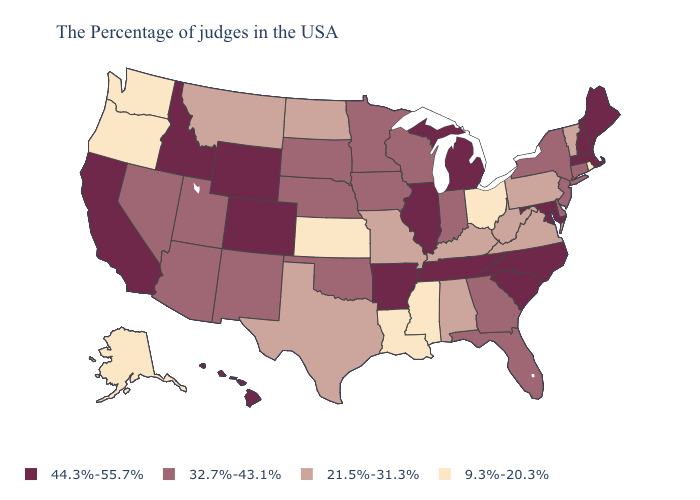Which states have the highest value in the USA?
Write a very short answer. Maine, Massachusetts, New Hampshire, Maryland, North Carolina, South Carolina, Michigan, Tennessee, Illinois, Arkansas, Wyoming, Colorado, Idaho, California, Hawaii. Name the states that have a value in the range 9.3%-20.3%?
Answer briefly. Rhode Island, Ohio, Mississippi, Louisiana, Kansas, Washington, Oregon, Alaska. Name the states that have a value in the range 21.5%-31.3%?
Concise answer only. Vermont, Pennsylvania, Virginia, West Virginia, Kentucky, Alabama, Missouri, Texas, North Dakota, Montana. What is the value of Tennessee?
Write a very short answer. 44.3%-55.7%. Name the states that have a value in the range 44.3%-55.7%?
Answer briefly. Maine, Massachusetts, New Hampshire, Maryland, North Carolina, South Carolina, Michigan, Tennessee, Illinois, Arkansas, Wyoming, Colorado, Idaho, California, Hawaii. How many symbols are there in the legend?
Keep it brief. 4. Which states have the lowest value in the USA?
Answer briefly. Rhode Island, Ohio, Mississippi, Louisiana, Kansas, Washington, Oregon, Alaska. Among the states that border Oregon , which have the highest value?
Give a very brief answer. Idaho, California. What is the value of Oregon?
Short answer required. 9.3%-20.3%. Name the states that have a value in the range 21.5%-31.3%?
Short answer required. Vermont, Pennsylvania, Virginia, West Virginia, Kentucky, Alabama, Missouri, Texas, North Dakota, Montana. Name the states that have a value in the range 21.5%-31.3%?
Be succinct. Vermont, Pennsylvania, Virginia, West Virginia, Kentucky, Alabama, Missouri, Texas, North Dakota, Montana. Does Montana have the highest value in the USA?
Give a very brief answer. No. Does Rhode Island have the lowest value in the Northeast?
Write a very short answer. Yes. Does Hawaii have the lowest value in the USA?
Keep it brief. No. Among the states that border Nebraska , does South Dakota have the lowest value?
Write a very short answer. No. 